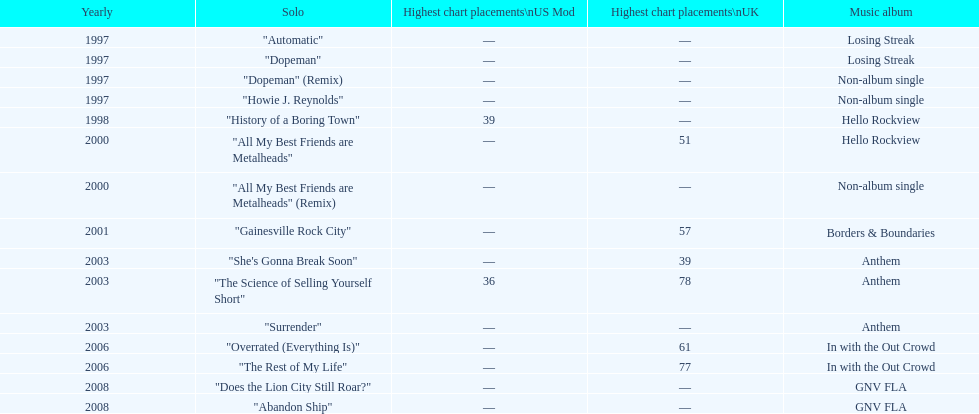Which year has the most singles? 1997. 